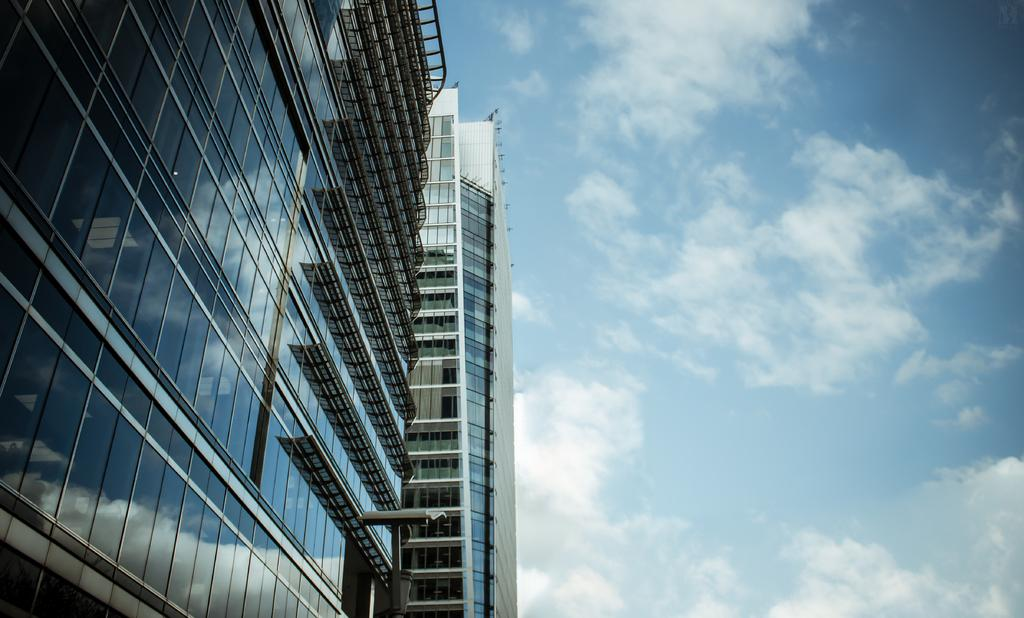What type of structure is in the picture? There is a multi-storied building in the picture. What feature can be observed on the building? The building has glass windows. What is the condition of the sky in the picture? The sky is clear in the picture. How many balloons are tied to the cart in the garden in the image? There is no cart, garden, or balloons present in the image; it features a multi-storied building with glass windows and a clear sky. 